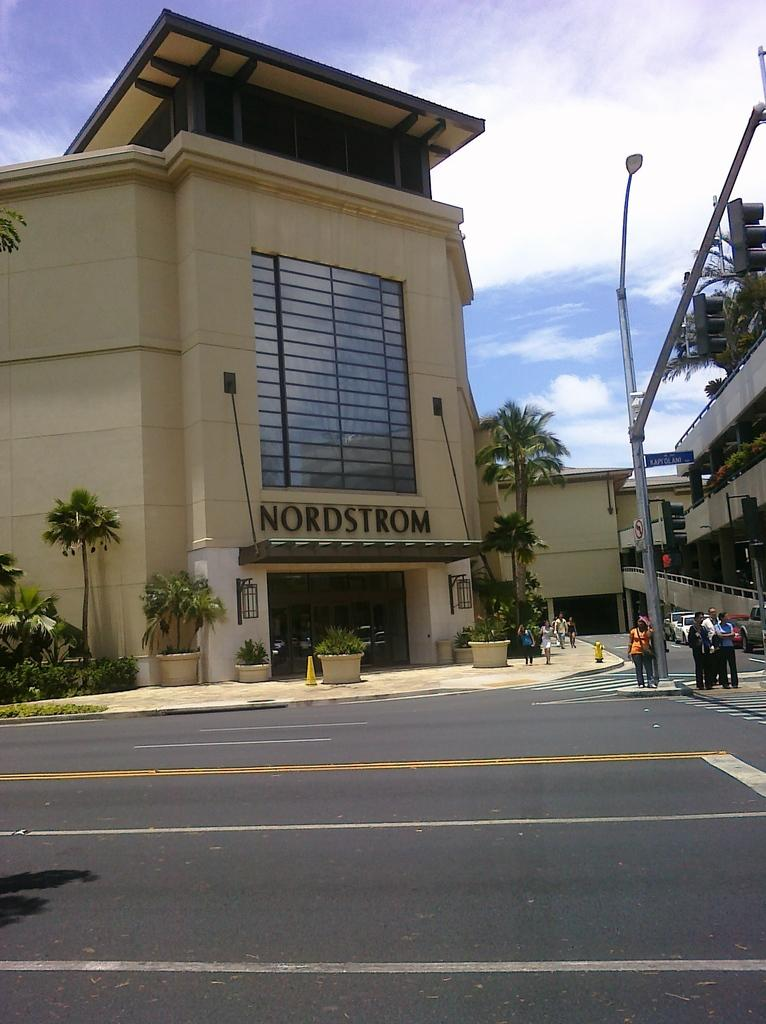<image>
Provide a brief description of the given image. A Nordstrom store at a city street where pedestrians are crossing. 